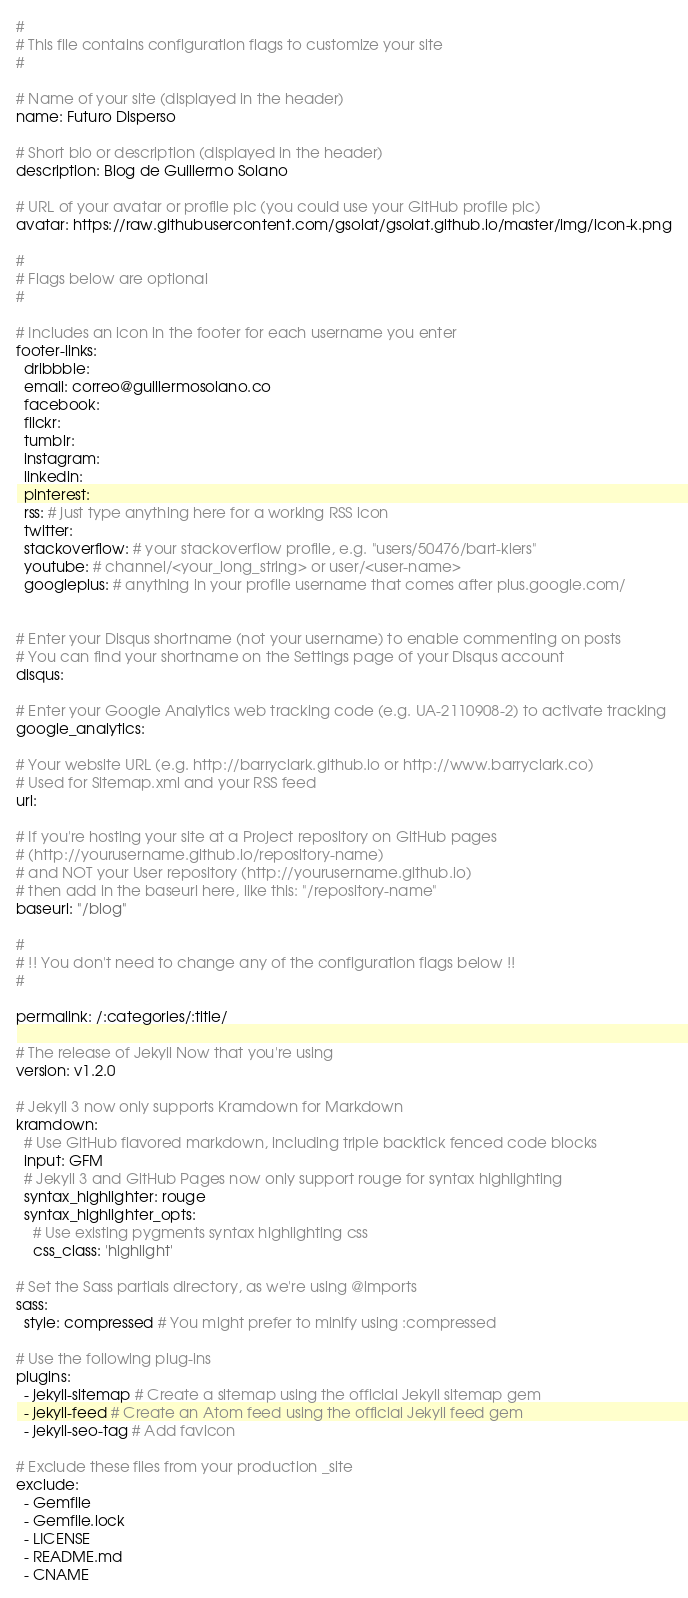<code> <loc_0><loc_0><loc_500><loc_500><_YAML_>#
# This file contains configuration flags to customize your site
#

# Name of your site (displayed in the header)
name: Futuro Disperso

# Short bio or description (displayed in the header)
description: Blog de Guillermo Solano

# URL of your avatar or profile pic (you could use your GitHub profile pic)
avatar: https://raw.githubusercontent.com/gsolat/gsolat.github.io/master/img/icon-k.png

#
# Flags below are optional
#

# Includes an icon in the footer for each username you enter
footer-links:
  dribbble:
  email: correo@guillermosolano.co
  facebook:
  flickr:
  tumblr:
  instagram:
  linkedin:
  pinterest:
  rss: # just type anything here for a working RSS icon
  twitter:
  stackoverflow: # your stackoverflow profile, e.g. "users/50476/bart-kiers"
  youtube: # channel/<your_long_string> or user/<user-name>
  googleplus: # anything in your profile username that comes after plus.google.com/


# Enter your Disqus shortname (not your username) to enable commenting on posts
# You can find your shortname on the Settings page of your Disqus account
disqus:

# Enter your Google Analytics web tracking code (e.g. UA-2110908-2) to activate tracking
google_analytics:

# Your website URL (e.g. http://barryclark.github.io or http://www.barryclark.co)
# Used for Sitemap.xml and your RSS feed
url:

# If you're hosting your site at a Project repository on GitHub pages
# (http://yourusername.github.io/repository-name)
# and NOT your User repository (http://yourusername.github.io)
# then add in the baseurl here, like this: "/repository-name"
baseurl: "/blog"

#
# !! You don't need to change any of the configuration flags below !!
#

permalink: /:categories/:title/

# The release of Jekyll Now that you're using
version: v1.2.0

# Jekyll 3 now only supports Kramdown for Markdown
kramdown:
  # Use GitHub flavored markdown, including triple backtick fenced code blocks
  input: GFM
  # Jekyll 3 and GitHub Pages now only support rouge for syntax highlighting
  syntax_highlighter: rouge
  syntax_highlighter_opts:
    # Use existing pygments syntax highlighting css
    css_class: 'highlight'

# Set the Sass partials directory, as we're using @imports
sass:
  style: compressed # You might prefer to minify using :compressed

# Use the following plug-ins
plugins:
  - jekyll-sitemap # Create a sitemap using the official Jekyll sitemap gem
  - jekyll-feed # Create an Atom feed using the official Jekyll feed gem
  - jekyll-seo-tag # Add favicon

# Exclude these files from your production _site
exclude:
  - Gemfile
  - Gemfile.lock
  - LICENSE
  - README.md
  - CNAME
</code> 